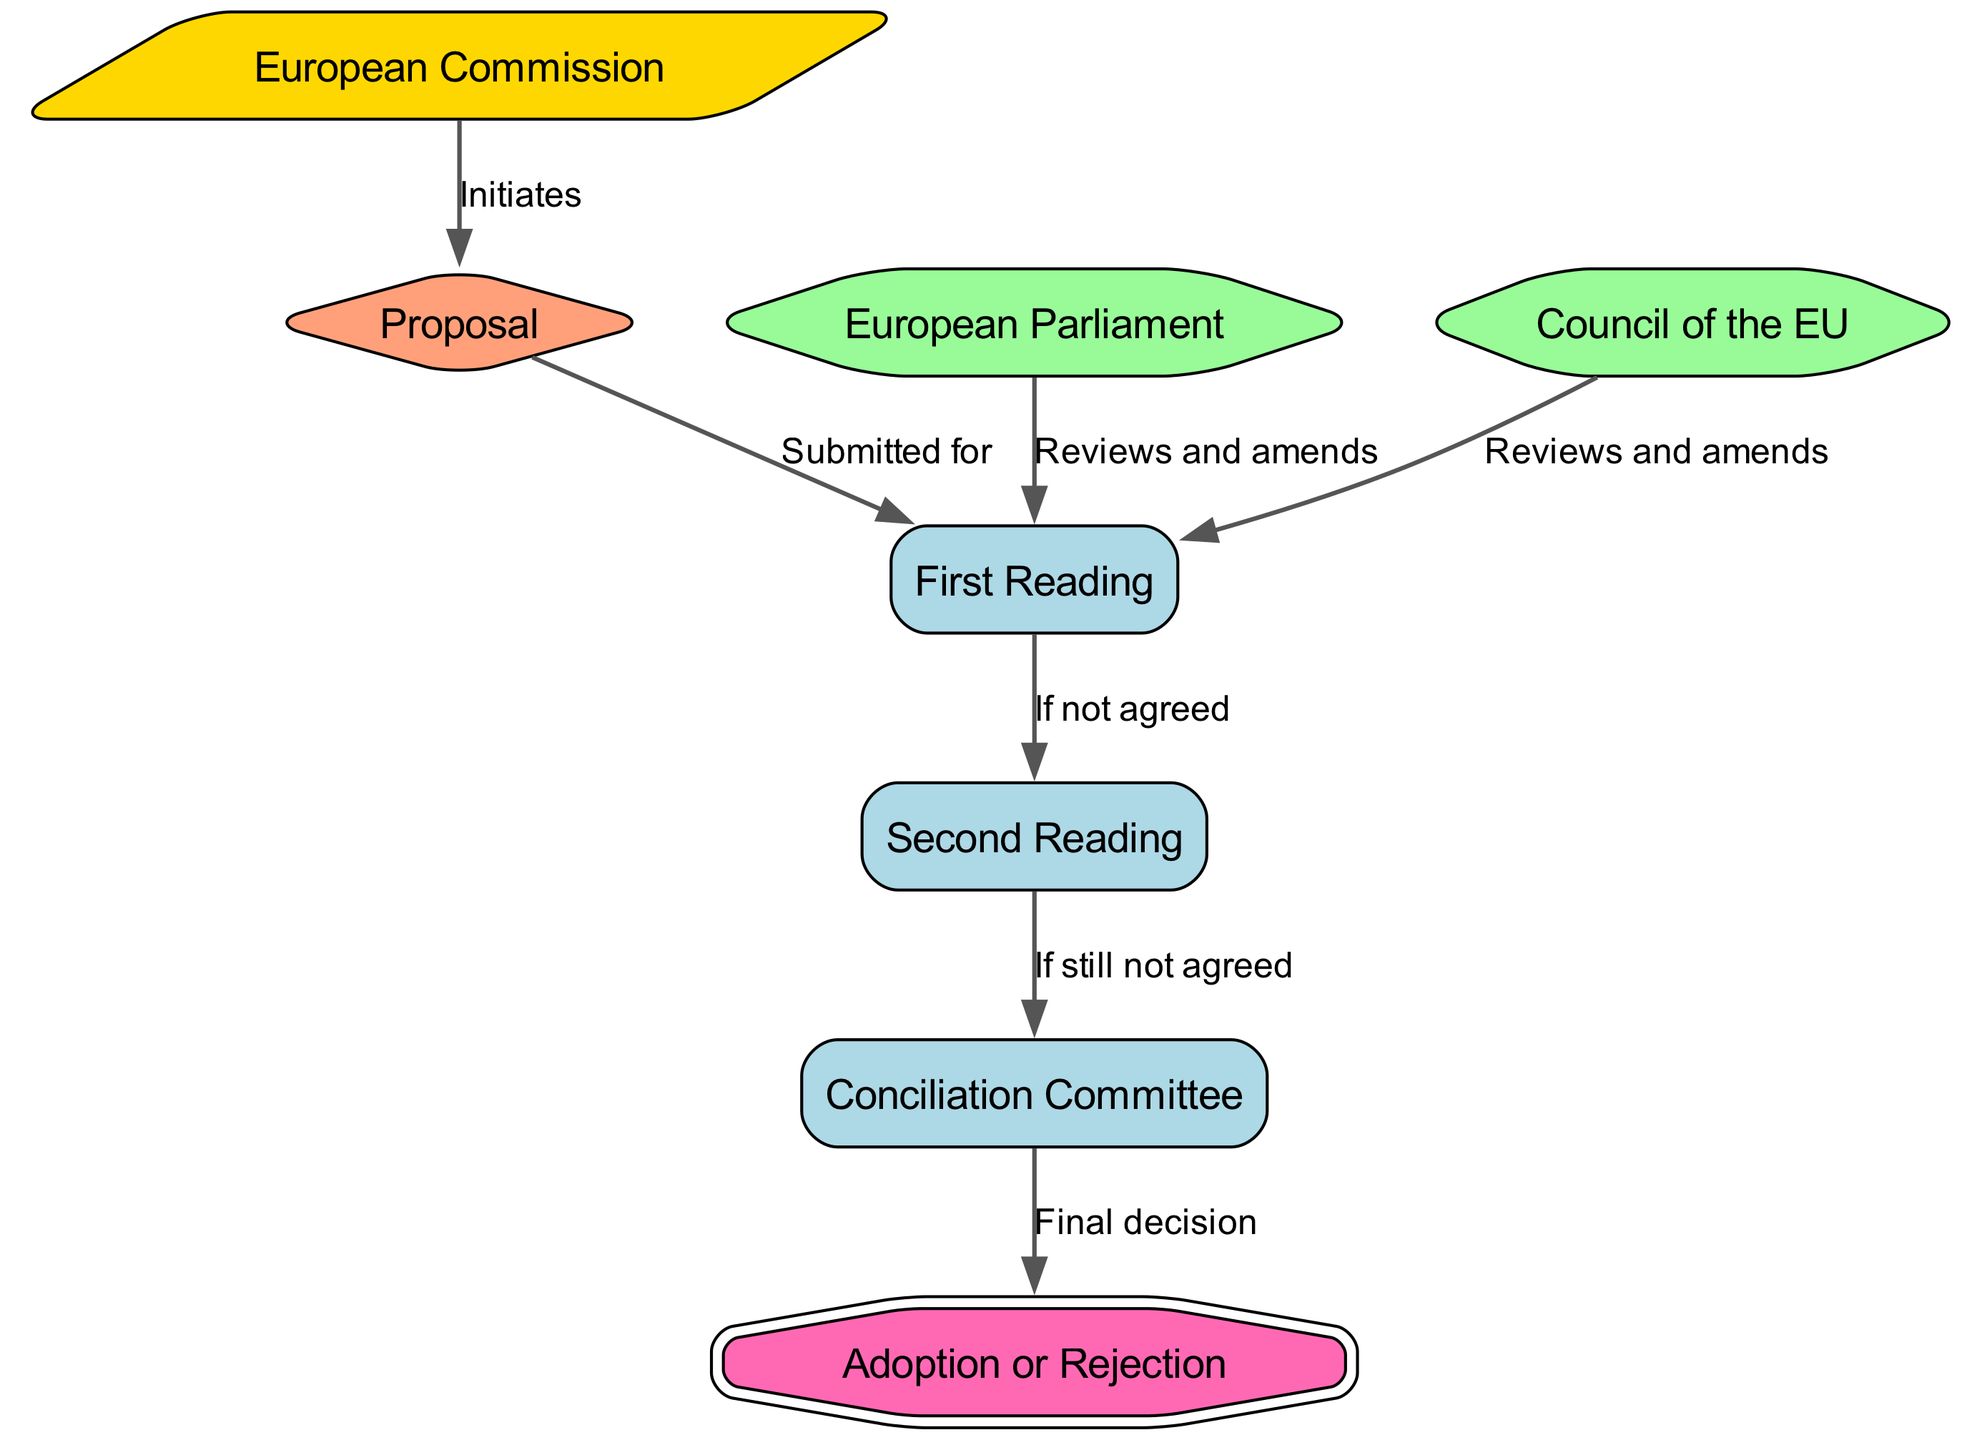What node initiates the proposal process? The diagram shows that the "European Commission" is the node that initiates the proposal process, as indicated by the edge labeled "Initiates" from node 1 to node 4.
Answer: European Commission How many nodes are present in the diagram? By counting the nodes listed, there are 8 nodes in total in the diagram, as indicated in the data provided.
Answer: 8 What is the shape of the "Proposal" node? The diagram specifies that the "Proposal" node (node 4) is represented with a diamond shape, as indicated by the node's attributes in the code.
Answer: Diamond Which two entities review and amend during the first reading process? The diagram shows that both the "European Parliament" (node 2) and the "Council of the EU" (node 3) review and amend during the first reading process, as demonstrated by edges directed towards node 5 from both nodes.
Answer: European Parliament and Council of the EU What is the outcome if the proposal is not agreed upon in the first reading? According to the diagram, if the proposal is not agreed upon in the first reading (node 5), it moves to the second reading (node 6), which is indicated by the edge labeled "If not agreed."
Answer: Moves to second reading What is the final decision node after the Conciliation Committee? The diagram indicates that after the Conciliation Committee (node 7), the final decision is represented by the "Adoption or Rejection" node (node 8), as shown by the edge labeled "Final decision."
Answer: Adoption or Rejection What happens if the proposal is still not agreed upon during the second reading? The diagram points out that if the proposal is still not agreed upon in the second reading (node 6), it goes to the Conciliation Committee (node 7), as depicted by the edge labeled "If still not agreed."
Answer: Goes to Conciliation Committee Which node is designated as the starting point of the decision-making process? The diagram clearly indicates that the starting point of the decision-making process is the "European Commission," which initiates the process by making a proposal.
Answer: European Commission 